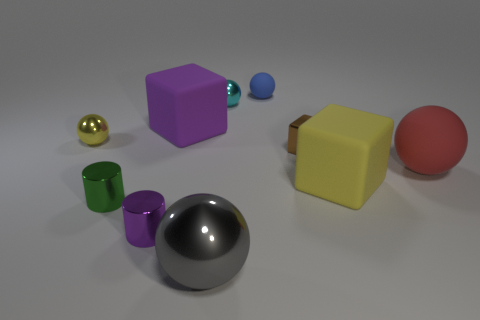How many other things are there of the same color as the tiny block? Upon examining the objects, it appears that there are no other items matching the exact color of the tiny blue block. 